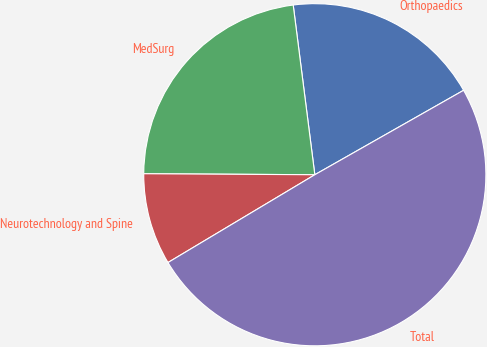Convert chart. <chart><loc_0><loc_0><loc_500><loc_500><pie_chart><fcel>Orthopaedics<fcel>MedSurg<fcel>Neurotechnology and Spine<fcel>Total<nl><fcel>18.8%<fcel>22.89%<fcel>8.67%<fcel>49.64%<nl></chart> 